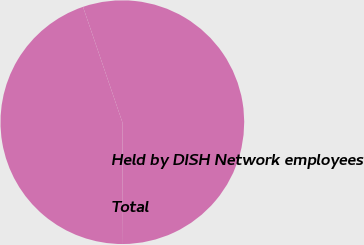<chart> <loc_0><loc_0><loc_500><loc_500><pie_chart><fcel>Held by DISH Network employees<fcel>Total<nl><fcel>44.85%<fcel>55.15%<nl></chart> 